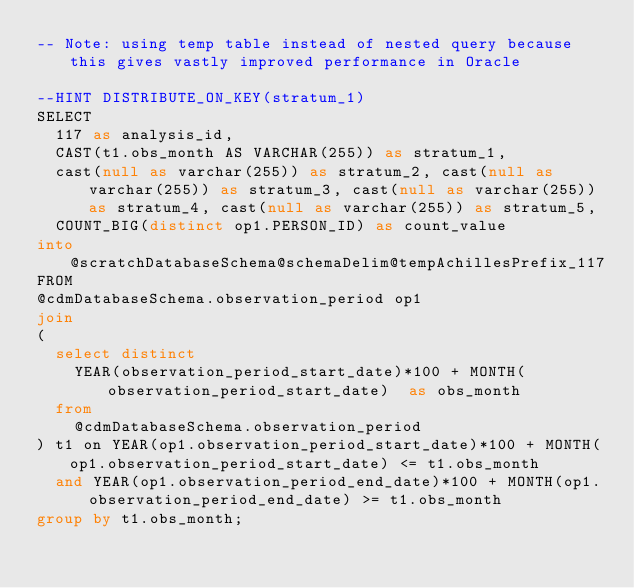<code> <loc_0><loc_0><loc_500><loc_500><_SQL_>-- Note: using temp table instead of nested query because this gives vastly improved performance in Oracle

--HINT DISTRIBUTE_ON_KEY(stratum_1)
SELECT
  117 as analysis_id,  
	CAST(t1.obs_month AS VARCHAR(255)) as stratum_1,
	cast(null as varchar(255)) as stratum_2, cast(null as varchar(255)) as stratum_3, cast(null as varchar(255)) as stratum_4, cast(null as varchar(255)) as stratum_5,
	COUNT_BIG(distinct op1.PERSON_ID) as count_value
into @scratchDatabaseSchema@schemaDelim@tempAchillesPrefix_117
FROM
@cdmDatabaseSchema.observation_period op1
join 
(
  select distinct 
    YEAR(observation_period_start_date)*100 + MONTH(observation_period_start_date)  as obs_month
  from 
    @cdmDatabaseSchema.observation_period
) t1 on YEAR(op1.observation_period_start_date)*100 + MONTH(op1.observation_period_start_date) <= t1.obs_month
	and YEAR(op1.observation_period_end_date)*100 + MONTH(op1.observation_period_end_date) >= t1.obs_month
group by t1.obs_month;</code> 